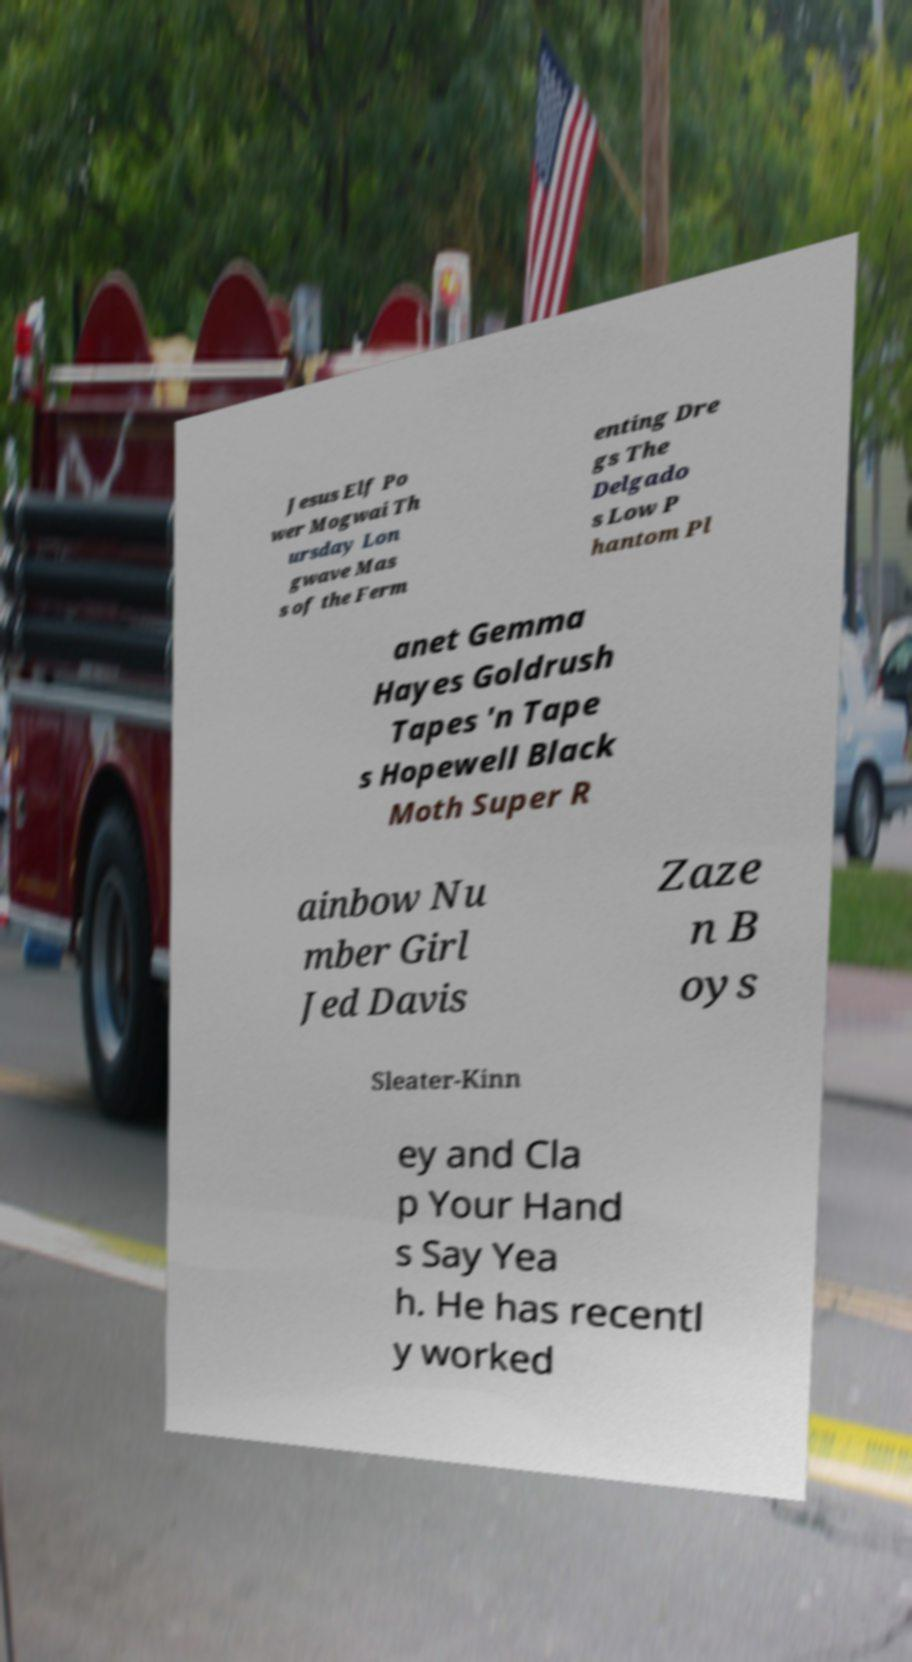I need the written content from this picture converted into text. Can you do that? Jesus Elf Po wer Mogwai Th ursday Lon gwave Mas s of the Ferm enting Dre gs The Delgado s Low P hantom Pl anet Gemma Hayes Goldrush Tapes 'n Tape s Hopewell Black Moth Super R ainbow Nu mber Girl Jed Davis Zaze n B oys Sleater-Kinn ey and Cla p Your Hand s Say Yea h. He has recentl y worked 